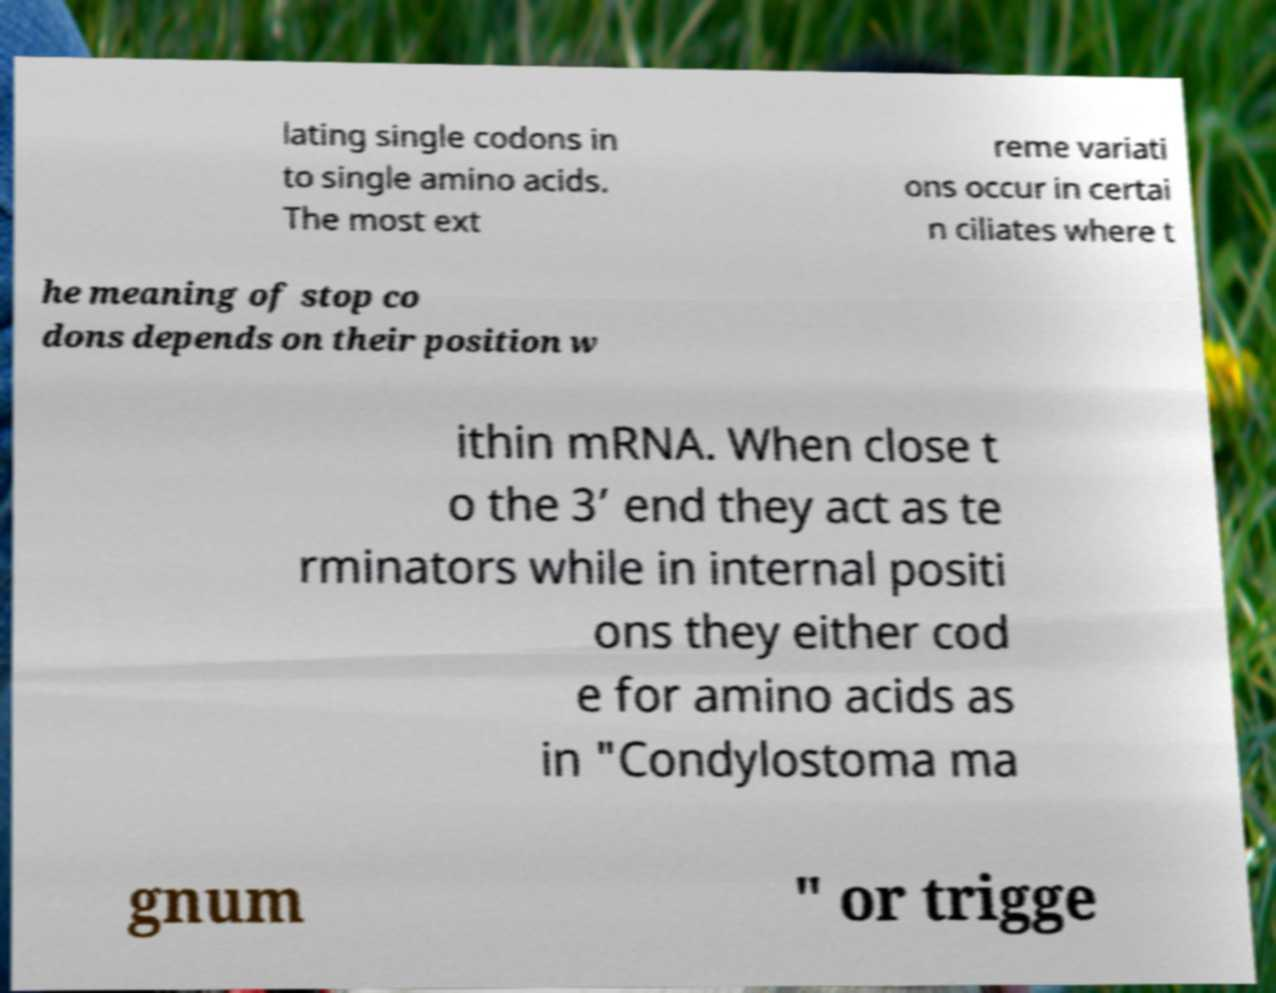Could you assist in decoding the text presented in this image and type it out clearly? lating single codons in to single amino acids. The most ext reme variati ons occur in certai n ciliates where t he meaning of stop co dons depends on their position w ithin mRNA. When close t o the 3’ end they act as te rminators while in internal positi ons they either cod e for amino acids as in "Condylostoma ma gnum " or trigge 